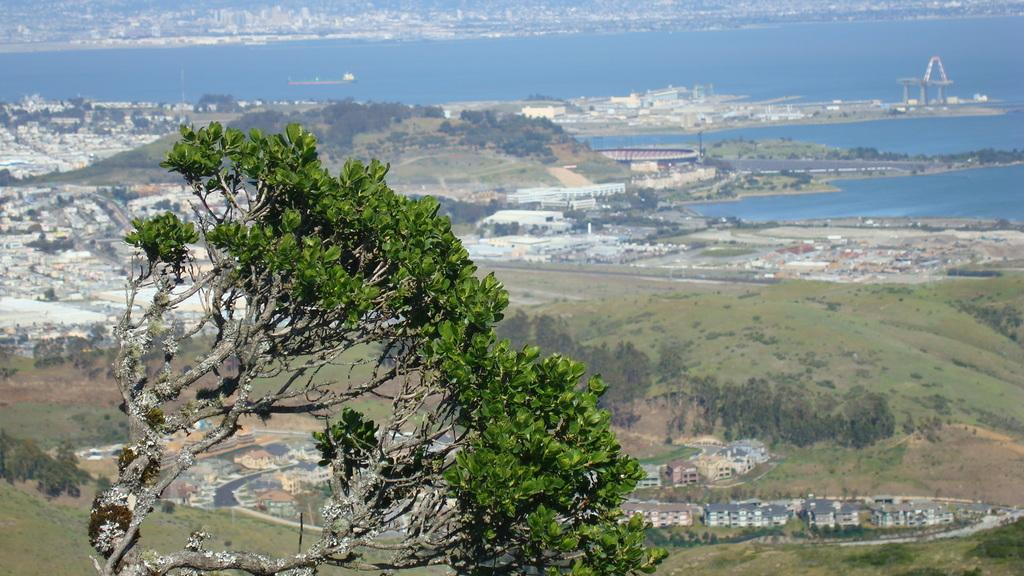What is located in the foreground of the picture? There is a tree in the foreground of the picture. What can be seen in the background of the picture? In the background, there are buildings, roads, a stadium, water, trees, mountains, and a boat on the water. What type of mine can be seen in the picture? There is no mine present in the picture. What trail leads to the mountains in the background? The image does not show a trail leading to the mountains; it only shows the mountains in the background. 